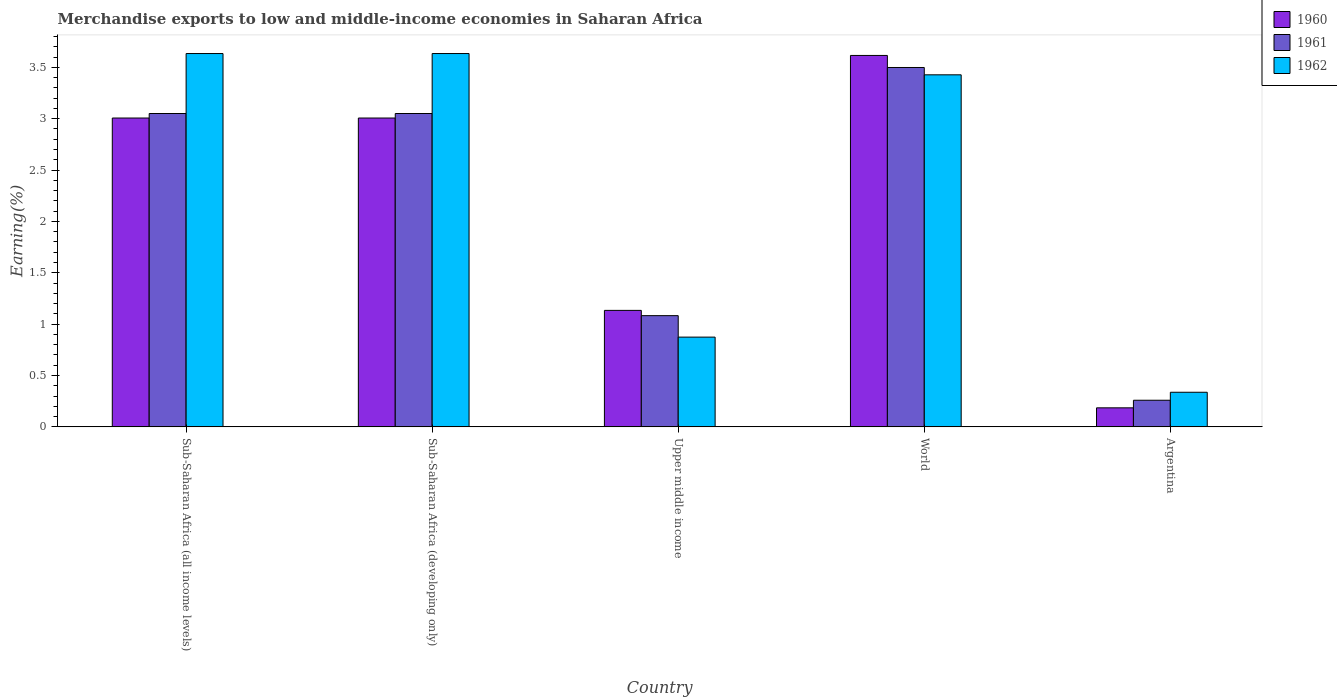How many different coloured bars are there?
Provide a short and direct response. 3. Are the number of bars per tick equal to the number of legend labels?
Give a very brief answer. Yes. Are the number of bars on each tick of the X-axis equal?
Make the answer very short. Yes. In how many cases, is the number of bars for a given country not equal to the number of legend labels?
Your answer should be compact. 0. What is the percentage of amount earned from merchandise exports in 1961 in Sub-Saharan Africa (developing only)?
Offer a very short reply. 3.05. Across all countries, what is the maximum percentage of amount earned from merchandise exports in 1961?
Provide a short and direct response. 3.5. Across all countries, what is the minimum percentage of amount earned from merchandise exports in 1960?
Your answer should be very brief. 0.19. In which country was the percentage of amount earned from merchandise exports in 1960 maximum?
Provide a short and direct response. World. What is the total percentage of amount earned from merchandise exports in 1961 in the graph?
Ensure brevity in your answer.  10.94. What is the difference between the percentage of amount earned from merchandise exports in 1962 in Sub-Saharan Africa (all income levels) and that in Upper middle income?
Provide a short and direct response. 2.76. What is the difference between the percentage of amount earned from merchandise exports in 1962 in World and the percentage of amount earned from merchandise exports in 1961 in Upper middle income?
Offer a terse response. 2.34. What is the average percentage of amount earned from merchandise exports in 1960 per country?
Give a very brief answer. 2.19. What is the difference between the percentage of amount earned from merchandise exports of/in 1961 and percentage of amount earned from merchandise exports of/in 1962 in Sub-Saharan Africa (all income levels)?
Make the answer very short. -0.58. What is the ratio of the percentage of amount earned from merchandise exports in 1962 in Argentina to that in Sub-Saharan Africa (all income levels)?
Offer a terse response. 0.09. What is the difference between the highest and the second highest percentage of amount earned from merchandise exports in 1960?
Offer a very short reply. -0.61. What is the difference between the highest and the lowest percentage of amount earned from merchandise exports in 1960?
Offer a very short reply. 3.43. In how many countries, is the percentage of amount earned from merchandise exports in 1961 greater than the average percentage of amount earned from merchandise exports in 1961 taken over all countries?
Provide a short and direct response. 3. Is the sum of the percentage of amount earned from merchandise exports in 1960 in Argentina and Upper middle income greater than the maximum percentage of amount earned from merchandise exports in 1962 across all countries?
Your response must be concise. No. What does the 3rd bar from the left in Upper middle income represents?
Make the answer very short. 1962. What is the difference between two consecutive major ticks on the Y-axis?
Give a very brief answer. 0.5. Are the values on the major ticks of Y-axis written in scientific E-notation?
Provide a short and direct response. No. How are the legend labels stacked?
Give a very brief answer. Vertical. What is the title of the graph?
Provide a succinct answer. Merchandise exports to low and middle-income economies in Saharan Africa. Does "1982" appear as one of the legend labels in the graph?
Provide a succinct answer. No. What is the label or title of the X-axis?
Ensure brevity in your answer.  Country. What is the label or title of the Y-axis?
Provide a succinct answer. Earning(%). What is the Earning(%) of 1960 in Sub-Saharan Africa (all income levels)?
Provide a short and direct response. 3.01. What is the Earning(%) of 1961 in Sub-Saharan Africa (all income levels)?
Offer a very short reply. 3.05. What is the Earning(%) in 1962 in Sub-Saharan Africa (all income levels)?
Your response must be concise. 3.63. What is the Earning(%) of 1960 in Sub-Saharan Africa (developing only)?
Offer a terse response. 3.01. What is the Earning(%) of 1961 in Sub-Saharan Africa (developing only)?
Your response must be concise. 3.05. What is the Earning(%) of 1962 in Sub-Saharan Africa (developing only)?
Your response must be concise. 3.63. What is the Earning(%) of 1960 in Upper middle income?
Your answer should be very brief. 1.13. What is the Earning(%) in 1961 in Upper middle income?
Your response must be concise. 1.08. What is the Earning(%) in 1962 in Upper middle income?
Give a very brief answer. 0.87. What is the Earning(%) of 1960 in World?
Your response must be concise. 3.62. What is the Earning(%) in 1961 in World?
Provide a succinct answer. 3.5. What is the Earning(%) of 1962 in World?
Your answer should be compact. 3.43. What is the Earning(%) in 1960 in Argentina?
Provide a short and direct response. 0.19. What is the Earning(%) of 1961 in Argentina?
Give a very brief answer. 0.26. What is the Earning(%) in 1962 in Argentina?
Your response must be concise. 0.34. Across all countries, what is the maximum Earning(%) of 1960?
Make the answer very short. 3.62. Across all countries, what is the maximum Earning(%) of 1961?
Provide a short and direct response. 3.5. Across all countries, what is the maximum Earning(%) in 1962?
Keep it short and to the point. 3.63. Across all countries, what is the minimum Earning(%) in 1960?
Offer a very short reply. 0.19. Across all countries, what is the minimum Earning(%) of 1961?
Offer a terse response. 0.26. Across all countries, what is the minimum Earning(%) of 1962?
Offer a very short reply. 0.34. What is the total Earning(%) of 1960 in the graph?
Make the answer very short. 10.95. What is the total Earning(%) of 1961 in the graph?
Provide a short and direct response. 10.94. What is the total Earning(%) of 1962 in the graph?
Your response must be concise. 11.91. What is the difference between the Earning(%) of 1960 in Sub-Saharan Africa (all income levels) and that in Sub-Saharan Africa (developing only)?
Offer a very short reply. 0. What is the difference between the Earning(%) of 1961 in Sub-Saharan Africa (all income levels) and that in Sub-Saharan Africa (developing only)?
Your answer should be compact. 0. What is the difference between the Earning(%) in 1962 in Sub-Saharan Africa (all income levels) and that in Sub-Saharan Africa (developing only)?
Make the answer very short. 0. What is the difference between the Earning(%) of 1960 in Sub-Saharan Africa (all income levels) and that in Upper middle income?
Offer a very short reply. 1.87. What is the difference between the Earning(%) in 1961 in Sub-Saharan Africa (all income levels) and that in Upper middle income?
Your answer should be very brief. 1.97. What is the difference between the Earning(%) in 1962 in Sub-Saharan Africa (all income levels) and that in Upper middle income?
Ensure brevity in your answer.  2.76. What is the difference between the Earning(%) of 1960 in Sub-Saharan Africa (all income levels) and that in World?
Keep it short and to the point. -0.61. What is the difference between the Earning(%) of 1961 in Sub-Saharan Africa (all income levels) and that in World?
Ensure brevity in your answer.  -0.45. What is the difference between the Earning(%) in 1962 in Sub-Saharan Africa (all income levels) and that in World?
Offer a very short reply. 0.21. What is the difference between the Earning(%) of 1960 in Sub-Saharan Africa (all income levels) and that in Argentina?
Your answer should be compact. 2.82. What is the difference between the Earning(%) of 1961 in Sub-Saharan Africa (all income levels) and that in Argentina?
Provide a succinct answer. 2.79. What is the difference between the Earning(%) in 1962 in Sub-Saharan Africa (all income levels) and that in Argentina?
Provide a short and direct response. 3.3. What is the difference between the Earning(%) of 1960 in Sub-Saharan Africa (developing only) and that in Upper middle income?
Ensure brevity in your answer.  1.87. What is the difference between the Earning(%) of 1961 in Sub-Saharan Africa (developing only) and that in Upper middle income?
Ensure brevity in your answer.  1.97. What is the difference between the Earning(%) in 1962 in Sub-Saharan Africa (developing only) and that in Upper middle income?
Keep it short and to the point. 2.76. What is the difference between the Earning(%) in 1960 in Sub-Saharan Africa (developing only) and that in World?
Provide a short and direct response. -0.61. What is the difference between the Earning(%) of 1961 in Sub-Saharan Africa (developing only) and that in World?
Your answer should be very brief. -0.45. What is the difference between the Earning(%) of 1962 in Sub-Saharan Africa (developing only) and that in World?
Keep it short and to the point. 0.21. What is the difference between the Earning(%) in 1960 in Sub-Saharan Africa (developing only) and that in Argentina?
Keep it short and to the point. 2.82. What is the difference between the Earning(%) of 1961 in Sub-Saharan Africa (developing only) and that in Argentina?
Your answer should be very brief. 2.79. What is the difference between the Earning(%) of 1962 in Sub-Saharan Africa (developing only) and that in Argentina?
Offer a very short reply. 3.3. What is the difference between the Earning(%) in 1960 in Upper middle income and that in World?
Keep it short and to the point. -2.48. What is the difference between the Earning(%) of 1961 in Upper middle income and that in World?
Your answer should be compact. -2.42. What is the difference between the Earning(%) of 1962 in Upper middle income and that in World?
Offer a very short reply. -2.55. What is the difference between the Earning(%) in 1960 in Upper middle income and that in Argentina?
Your response must be concise. 0.95. What is the difference between the Earning(%) in 1961 in Upper middle income and that in Argentina?
Ensure brevity in your answer.  0.82. What is the difference between the Earning(%) of 1962 in Upper middle income and that in Argentina?
Your answer should be compact. 0.54. What is the difference between the Earning(%) of 1960 in World and that in Argentina?
Provide a short and direct response. 3.43. What is the difference between the Earning(%) of 1961 in World and that in Argentina?
Make the answer very short. 3.24. What is the difference between the Earning(%) of 1962 in World and that in Argentina?
Provide a succinct answer. 3.09. What is the difference between the Earning(%) of 1960 in Sub-Saharan Africa (all income levels) and the Earning(%) of 1961 in Sub-Saharan Africa (developing only)?
Make the answer very short. -0.04. What is the difference between the Earning(%) in 1960 in Sub-Saharan Africa (all income levels) and the Earning(%) in 1962 in Sub-Saharan Africa (developing only)?
Offer a terse response. -0.63. What is the difference between the Earning(%) in 1961 in Sub-Saharan Africa (all income levels) and the Earning(%) in 1962 in Sub-Saharan Africa (developing only)?
Provide a short and direct response. -0.58. What is the difference between the Earning(%) in 1960 in Sub-Saharan Africa (all income levels) and the Earning(%) in 1961 in Upper middle income?
Offer a terse response. 1.92. What is the difference between the Earning(%) of 1960 in Sub-Saharan Africa (all income levels) and the Earning(%) of 1962 in Upper middle income?
Your response must be concise. 2.13. What is the difference between the Earning(%) of 1961 in Sub-Saharan Africa (all income levels) and the Earning(%) of 1962 in Upper middle income?
Keep it short and to the point. 2.18. What is the difference between the Earning(%) of 1960 in Sub-Saharan Africa (all income levels) and the Earning(%) of 1961 in World?
Provide a succinct answer. -0.49. What is the difference between the Earning(%) in 1960 in Sub-Saharan Africa (all income levels) and the Earning(%) in 1962 in World?
Provide a succinct answer. -0.42. What is the difference between the Earning(%) in 1961 in Sub-Saharan Africa (all income levels) and the Earning(%) in 1962 in World?
Your answer should be compact. -0.38. What is the difference between the Earning(%) in 1960 in Sub-Saharan Africa (all income levels) and the Earning(%) in 1961 in Argentina?
Provide a short and direct response. 2.75. What is the difference between the Earning(%) of 1960 in Sub-Saharan Africa (all income levels) and the Earning(%) of 1962 in Argentina?
Your response must be concise. 2.67. What is the difference between the Earning(%) of 1961 in Sub-Saharan Africa (all income levels) and the Earning(%) of 1962 in Argentina?
Provide a succinct answer. 2.71. What is the difference between the Earning(%) in 1960 in Sub-Saharan Africa (developing only) and the Earning(%) in 1961 in Upper middle income?
Your response must be concise. 1.92. What is the difference between the Earning(%) in 1960 in Sub-Saharan Africa (developing only) and the Earning(%) in 1962 in Upper middle income?
Offer a terse response. 2.13. What is the difference between the Earning(%) in 1961 in Sub-Saharan Africa (developing only) and the Earning(%) in 1962 in Upper middle income?
Ensure brevity in your answer.  2.18. What is the difference between the Earning(%) of 1960 in Sub-Saharan Africa (developing only) and the Earning(%) of 1961 in World?
Provide a succinct answer. -0.49. What is the difference between the Earning(%) of 1960 in Sub-Saharan Africa (developing only) and the Earning(%) of 1962 in World?
Provide a succinct answer. -0.42. What is the difference between the Earning(%) in 1961 in Sub-Saharan Africa (developing only) and the Earning(%) in 1962 in World?
Offer a very short reply. -0.38. What is the difference between the Earning(%) in 1960 in Sub-Saharan Africa (developing only) and the Earning(%) in 1961 in Argentina?
Make the answer very short. 2.75. What is the difference between the Earning(%) of 1960 in Sub-Saharan Africa (developing only) and the Earning(%) of 1962 in Argentina?
Offer a very short reply. 2.67. What is the difference between the Earning(%) of 1961 in Sub-Saharan Africa (developing only) and the Earning(%) of 1962 in Argentina?
Offer a terse response. 2.71. What is the difference between the Earning(%) of 1960 in Upper middle income and the Earning(%) of 1961 in World?
Provide a succinct answer. -2.36. What is the difference between the Earning(%) of 1960 in Upper middle income and the Earning(%) of 1962 in World?
Give a very brief answer. -2.29. What is the difference between the Earning(%) in 1961 in Upper middle income and the Earning(%) in 1962 in World?
Give a very brief answer. -2.34. What is the difference between the Earning(%) in 1960 in Upper middle income and the Earning(%) in 1961 in Argentina?
Offer a terse response. 0.87. What is the difference between the Earning(%) in 1960 in Upper middle income and the Earning(%) in 1962 in Argentina?
Offer a terse response. 0.8. What is the difference between the Earning(%) of 1961 in Upper middle income and the Earning(%) of 1962 in Argentina?
Offer a terse response. 0.75. What is the difference between the Earning(%) in 1960 in World and the Earning(%) in 1961 in Argentina?
Keep it short and to the point. 3.36. What is the difference between the Earning(%) of 1960 in World and the Earning(%) of 1962 in Argentina?
Your answer should be compact. 3.28. What is the difference between the Earning(%) of 1961 in World and the Earning(%) of 1962 in Argentina?
Provide a short and direct response. 3.16. What is the average Earning(%) in 1960 per country?
Keep it short and to the point. 2.19. What is the average Earning(%) of 1961 per country?
Give a very brief answer. 2.19. What is the average Earning(%) of 1962 per country?
Provide a short and direct response. 2.38. What is the difference between the Earning(%) of 1960 and Earning(%) of 1961 in Sub-Saharan Africa (all income levels)?
Make the answer very short. -0.04. What is the difference between the Earning(%) of 1960 and Earning(%) of 1962 in Sub-Saharan Africa (all income levels)?
Your answer should be very brief. -0.63. What is the difference between the Earning(%) of 1961 and Earning(%) of 1962 in Sub-Saharan Africa (all income levels)?
Your answer should be very brief. -0.58. What is the difference between the Earning(%) in 1960 and Earning(%) in 1961 in Sub-Saharan Africa (developing only)?
Give a very brief answer. -0.04. What is the difference between the Earning(%) in 1960 and Earning(%) in 1962 in Sub-Saharan Africa (developing only)?
Provide a short and direct response. -0.63. What is the difference between the Earning(%) of 1961 and Earning(%) of 1962 in Sub-Saharan Africa (developing only)?
Offer a terse response. -0.58. What is the difference between the Earning(%) in 1960 and Earning(%) in 1961 in Upper middle income?
Provide a succinct answer. 0.05. What is the difference between the Earning(%) in 1960 and Earning(%) in 1962 in Upper middle income?
Your answer should be very brief. 0.26. What is the difference between the Earning(%) of 1961 and Earning(%) of 1962 in Upper middle income?
Offer a terse response. 0.21. What is the difference between the Earning(%) in 1960 and Earning(%) in 1961 in World?
Provide a short and direct response. 0.12. What is the difference between the Earning(%) of 1960 and Earning(%) of 1962 in World?
Offer a terse response. 0.19. What is the difference between the Earning(%) in 1961 and Earning(%) in 1962 in World?
Your answer should be compact. 0.07. What is the difference between the Earning(%) in 1960 and Earning(%) in 1961 in Argentina?
Offer a very short reply. -0.07. What is the difference between the Earning(%) of 1960 and Earning(%) of 1962 in Argentina?
Provide a short and direct response. -0.15. What is the difference between the Earning(%) of 1961 and Earning(%) of 1962 in Argentina?
Your response must be concise. -0.08. What is the ratio of the Earning(%) in 1960 in Sub-Saharan Africa (all income levels) to that in Sub-Saharan Africa (developing only)?
Provide a short and direct response. 1. What is the ratio of the Earning(%) in 1960 in Sub-Saharan Africa (all income levels) to that in Upper middle income?
Ensure brevity in your answer.  2.65. What is the ratio of the Earning(%) in 1961 in Sub-Saharan Africa (all income levels) to that in Upper middle income?
Provide a succinct answer. 2.82. What is the ratio of the Earning(%) in 1962 in Sub-Saharan Africa (all income levels) to that in Upper middle income?
Ensure brevity in your answer.  4.16. What is the ratio of the Earning(%) of 1960 in Sub-Saharan Africa (all income levels) to that in World?
Provide a succinct answer. 0.83. What is the ratio of the Earning(%) in 1961 in Sub-Saharan Africa (all income levels) to that in World?
Keep it short and to the point. 0.87. What is the ratio of the Earning(%) in 1962 in Sub-Saharan Africa (all income levels) to that in World?
Offer a terse response. 1.06. What is the ratio of the Earning(%) of 1960 in Sub-Saharan Africa (all income levels) to that in Argentina?
Make the answer very short. 16.22. What is the ratio of the Earning(%) of 1961 in Sub-Saharan Africa (all income levels) to that in Argentina?
Your answer should be compact. 11.77. What is the ratio of the Earning(%) in 1962 in Sub-Saharan Africa (all income levels) to that in Argentina?
Your answer should be compact. 10.79. What is the ratio of the Earning(%) of 1960 in Sub-Saharan Africa (developing only) to that in Upper middle income?
Your answer should be compact. 2.65. What is the ratio of the Earning(%) of 1961 in Sub-Saharan Africa (developing only) to that in Upper middle income?
Make the answer very short. 2.82. What is the ratio of the Earning(%) of 1962 in Sub-Saharan Africa (developing only) to that in Upper middle income?
Your response must be concise. 4.16. What is the ratio of the Earning(%) of 1960 in Sub-Saharan Africa (developing only) to that in World?
Provide a short and direct response. 0.83. What is the ratio of the Earning(%) of 1961 in Sub-Saharan Africa (developing only) to that in World?
Make the answer very short. 0.87. What is the ratio of the Earning(%) in 1962 in Sub-Saharan Africa (developing only) to that in World?
Keep it short and to the point. 1.06. What is the ratio of the Earning(%) in 1960 in Sub-Saharan Africa (developing only) to that in Argentina?
Give a very brief answer. 16.22. What is the ratio of the Earning(%) in 1961 in Sub-Saharan Africa (developing only) to that in Argentina?
Ensure brevity in your answer.  11.77. What is the ratio of the Earning(%) of 1962 in Sub-Saharan Africa (developing only) to that in Argentina?
Keep it short and to the point. 10.79. What is the ratio of the Earning(%) in 1960 in Upper middle income to that in World?
Your answer should be very brief. 0.31. What is the ratio of the Earning(%) in 1961 in Upper middle income to that in World?
Make the answer very short. 0.31. What is the ratio of the Earning(%) in 1962 in Upper middle income to that in World?
Your response must be concise. 0.25. What is the ratio of the Earning(%) of 1960 in Upper middle income to that in Argentina?
Keep it short and to the point. 6.12. What is the ratio of the Earning(%) in 1961 in Upper middle income to that in Argentina?
Provide a succinct answer. 4.18. What is the ratio of the Earning(%) of 1962 in Upper middle income to that in Argentina?
Your answer should be very brief. 2.59. What is the ratio of the Earning(%) in 1960 in World to that in Argentina?
Make the answer very short. 19.51. What is the ratio of the Earning(%) of 1961 in World to that in Argentina?
Your response must be concise. 13.49. What is the ratio of the Earning(%) in 1962 in World to that in Argentina?
Provide a short and direct response. 10.17. What is the difference between the highest and the second highest Earning(%) in 1960?
Offer a terse response. 0.61. What is the difference between the highest and the second highest Earning(%) of 1961?
Your answer should be very brief. 0.45. What is the difference between the highest and the second highest Earning(%) of 1962?
Offer a very short reply. 0. What is the difference between the highest and the lowest Earning(%) in 1960?
Your response must be concise. 3.43. What is the difference between the highest and the lowest Earning(%) of 1961?
Make the answer very short. 3.24. What is the difference between the highest and the lowest Earning(%) in 1962?
Ensure brevity in your answer.  3.3. 